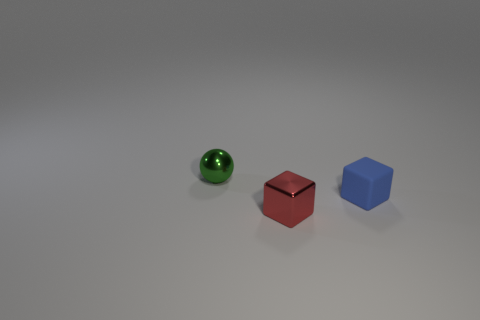Add 3 tiny green spheres. How many objects exist? 6 Subtract all balls. How many objects are left? 2 Add 2 matte cubes. How many matte cubes exist? 3 Subtract 0 green cylinders. How many objects are left? 3 Subtract all tiny red blocks. Subtract all small red blocks. How many objects are left? 1 Add 3 rubber cubes. How many rubber cubes are left? 4 